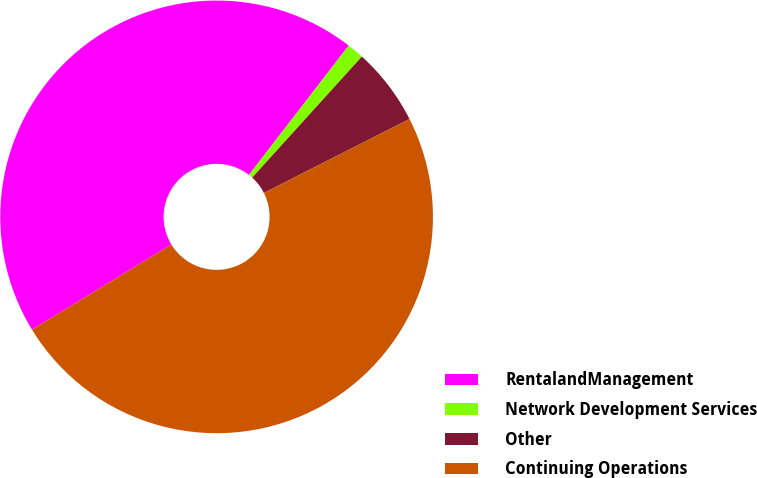Convert chart. <chart><loc_0><loc_0><loc_500><loc_500><pie_chart><fcel>RentalandManagement<fcel>Network Development Services<fcel>Other<fcel>Continuing Operations<nl><fcel>44.19%<fcel>1.26%<fcel>5.81%<fcel>48.74%<nl></chart> 